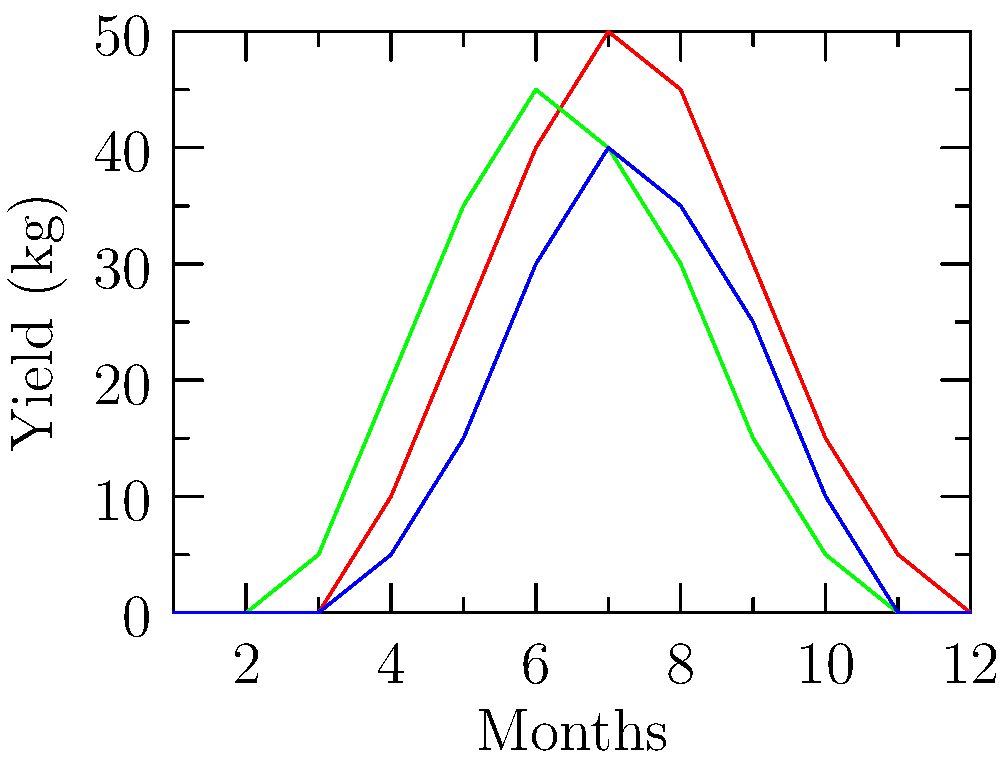As the organizer of a local food swap event, you're analyzing seasonal crop yields to plan for the upcoming year. The graph shows the monthly yield of tomatoes, cucumbers, and peppers. During which month does the combined yield of all three crops reach its peak? To find the month with the highest combined yield, we need to follow these steps:

1. Identify the yield for each crop in every month.
2. Add the yields of all three crops for each month.
3. Compare the combined yields to find the highest.

Let's examine the key months:

June (Month 6):
Tomatoes: 40 kg
Cucumbers: 45 kg
Peppers: 30 kg
Total: 40 + 45 + 30 = 115 kg

July (Month 7):
Tomatoes: 50 kg
Cucumbers: 40 kg
Peppers: 40 kg
Total: 50 + 40 + 40 = 130 kg

August (Month 8):
Tomatoes: 45 kg
Cucumbers: 30 kg
Peppers: 35 kg
Total: 45 + 30 + 35 = 110 kg

July has the highest combined yield at 130 kg, which is greater than both June (115 kg) and August (110 kg).
Answer: July 